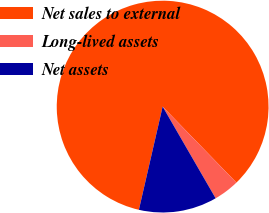<chart> <loc_0><loc_0><loc_500><loc_500><pie_chart><fcel>Net sales to external<fcel>Long-lived assets<fcel>Net assets<nl><fcel>84.14%<fcel>3.92%<fcel>11.94%<nl></chart> 